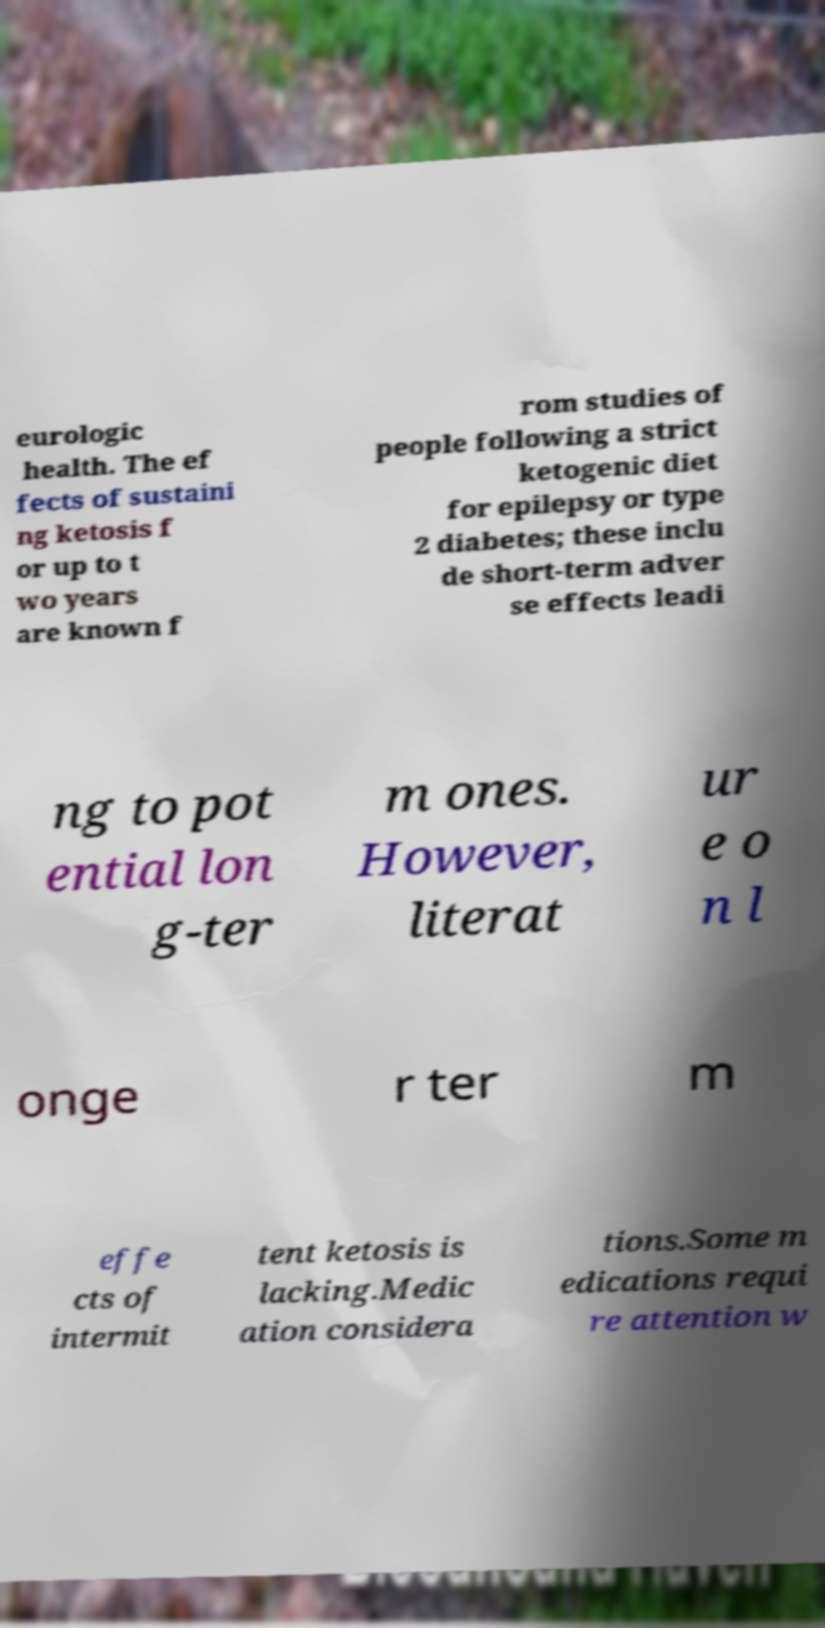Could you assist in decoding the text presented in this image and type it out clearly? eurologic health. The ef fects of sustaini ng ketosis f or up to t wo years are known f rom studies of people following a strict ketogenic diet for epilepsy or type 2 diabetes; these inclu de short-term adver se effects leadi ng to pot ential lon g-ter m ones. However, literat ur e o n l onge r ter m effe cts of intermit tent ketosis is lacking.Medic ation considera tions.Some m edications requi re attention w 